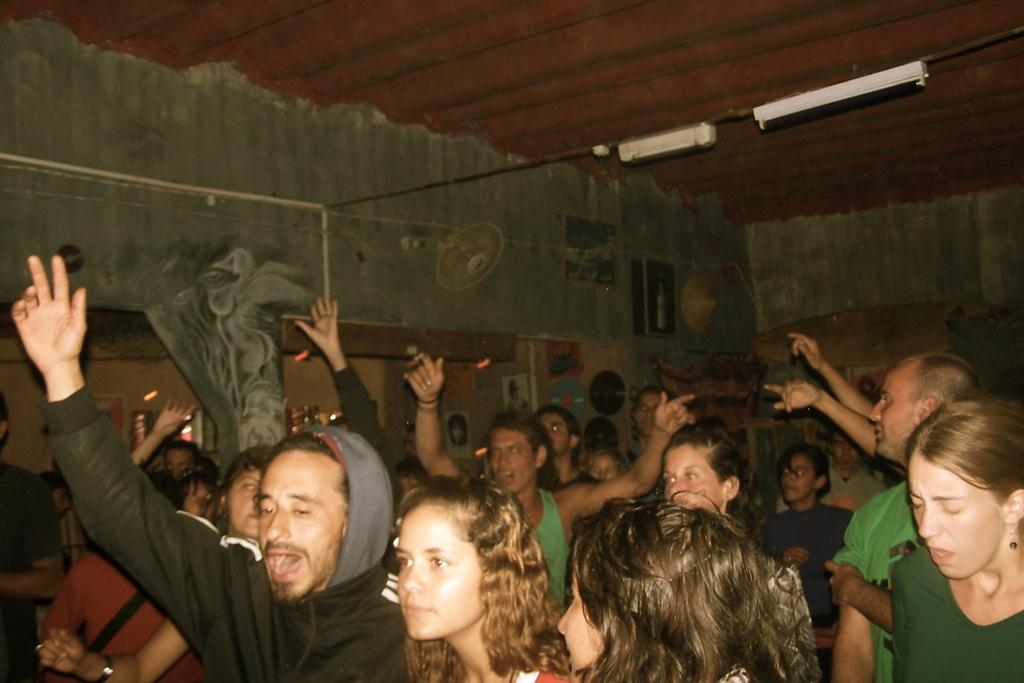Who or what is present in the image? There are people in the image. What can be seen at the top of the image? There are lights visible at the top of the image. What is on the wall in the background of the image? There are posters and discs on the wall in the background. What is visible in the background of the image? There is a fan visible in the background. What type of pear is hanging from the fan in the image? There is no pear present in the image, and the fan is not holding any fruit. 